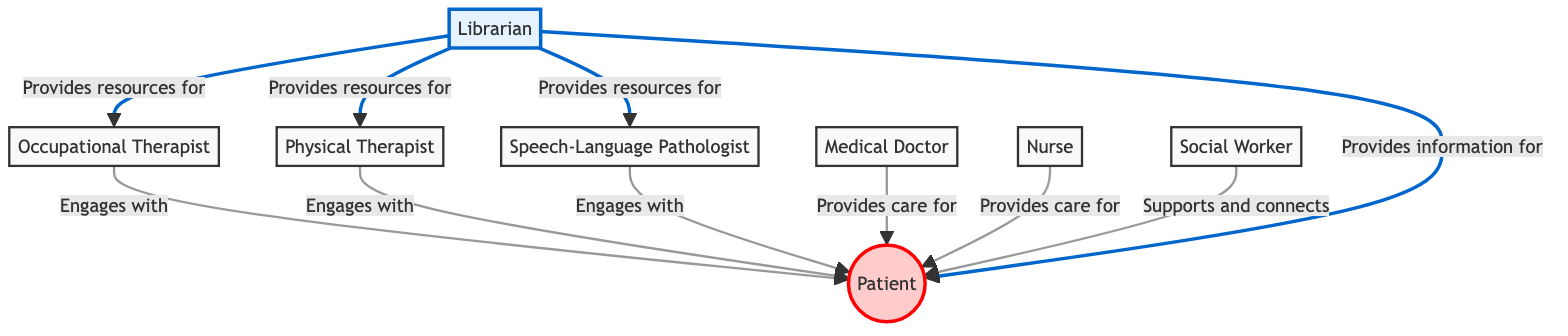What is the role of the librarian? The librarian's role is to curate and provide access to informational resources catering to diverse learning styles. This information can be found in the node labeled "Librarian" within the diagram.
Answer: Curates and provides access to informational resources catering to diverse learning styles How many nodes are there in the diagram? By counting each labeled role represented in the diagram, I identify that there are a total of eight distinct roles or entities. This includes all the professionals listed along with the patient and the librarian.
Answer: Eight Who does the nurse provide care for? The diagram indicates that the nurse provides care for the patient. This relationship is depicted in the edge connecting the nurse node to the patient node, with the label "Provides care for."
Answer: Patient Which professional does the librarian provide resources for? According to the diagram, the librarian provides resources for the occupational therapist, physical therapist, and speech-language pathologist. These relationships are connected with edges that indicate the librarian's supportive role in providing resources.
Answer: Occupational Therapist, Physical Therapist, Speech-Language Pathologist How many edges connect to the patient node? By examining the diagram, I see there are six edges connecting to the patient, which indicates multiple professionals engage with or provide care for the patient. The edges denote direct interactions from the various healthcare roles to the patient node.
Answer: Six What is the main focus of patient care in the diagram? The diagram indicates that the central focus of care is the patient, as highlighted in the patient node which connects to multiple healthcare professionals. The networking implies that all roles revolve around the patient's needs in a multidisciplinary team framework.
Answer: Patient 